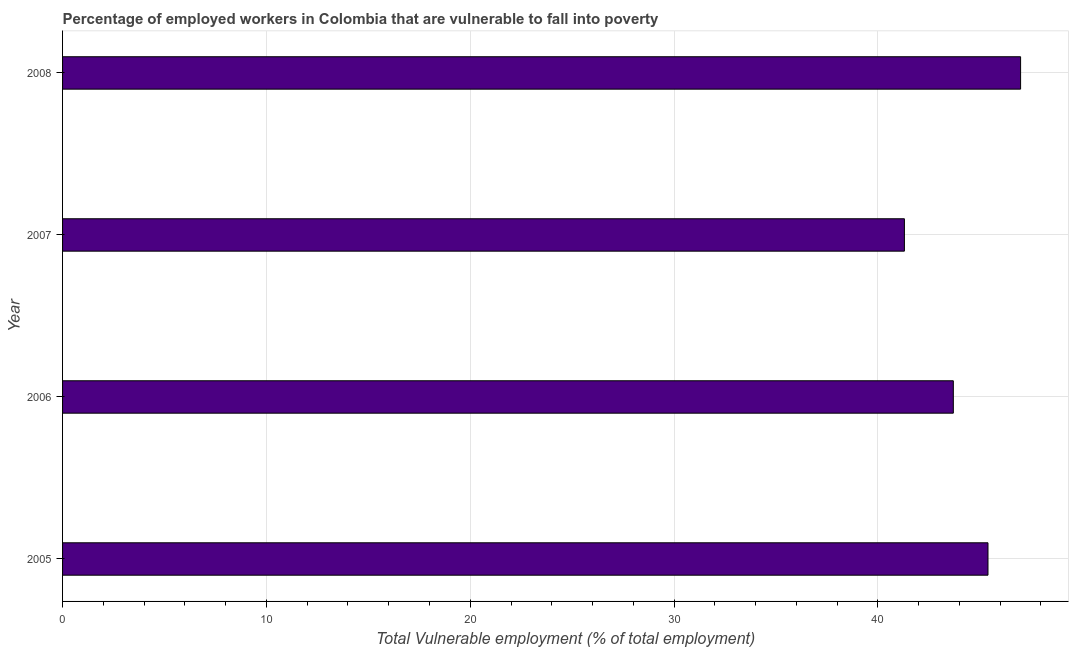Does the graph contain any zero values?
Keep it short and to the point. No. What is the title of the graph?
Offer a very short reply. Percentage of employed workers in Colombia that are vulnerable to fall into poverty. What is the label or title of the X-axis?
Your answer should be very brief. Total Vulnerable employment (% of total employment). What is the total vulnerable employment in 2005?
Offer a very short reply. 45.4. Across all years, what is the maximum total vulnerable employment?
Your response must be concise. 47. Across all years, what is the minimum total vulnerable employment?
Give a very brief answer. 41.3. In which year was the total vulnerable employment minimum?
Give a very brief answer. 2007. What is the sum of the total vulnerable employment?
Keep it short and to the point. 177.4. What is the average total vulnerable employment per year?
Provide a succinct answer. 44.35. What is the median total vulnerable employment?
Offer a very short reply. 44.55. In how many years, is the total vulnerable employment greater than 40 %?
Your answer should be very brief. 4. What is the ratio of the total vulnerable employment in 2006 to that in 2007?
Keep it short and to the point. 1.06. Is the difference between the total vulnerable employment in 2006 and 2007 greater than the difference between any two years?
Ensure brevity in your answer.  No. What is the difference between the highest and the lowest total vulnerable employment?
Offer a very short reply. 5.7. In how many years, is the total vulnerable employment greater than the average total vulnerable employment taken over all years?
Offer a very short reply. 2. How many bars are there?
Provide a short and direct response. 4. Are all the bars in the graph horizontal?
Offer a very short reply. Yes. How many years are there in the graph?
Offer a very short reply. 4. What is the Total Vulnerable employment (% of total employment) in 2005?
Make the answer very short. 45.4. What is the Total Vulnerable employment (% of total employment) in 2006?
Give a very brief answer. 43.7. What is the Total Vulnerable employment (% of total employment) in 2007?
Keep it short and to the point. 41.3. What is the ratio of the Total Vulnerable employment (% of total employment) in 2005 to that in 2006?
Provide a succinct answer. 1.04. What is the ratio of the Total Vulnerable employment (% of total employment) in 2005 to that in 2007?
Provide a short and direct response. 1.1. What is the ratio of the Total Vulnerable employment (% of total employment) in 2006 to that in 2007?
Ensure brevity in your answer.  1.06. What is the ratio of the Total Vulnerable employment (% of total employment) in 2007 to that in 2008?
Make the answer very short. 0.88. 